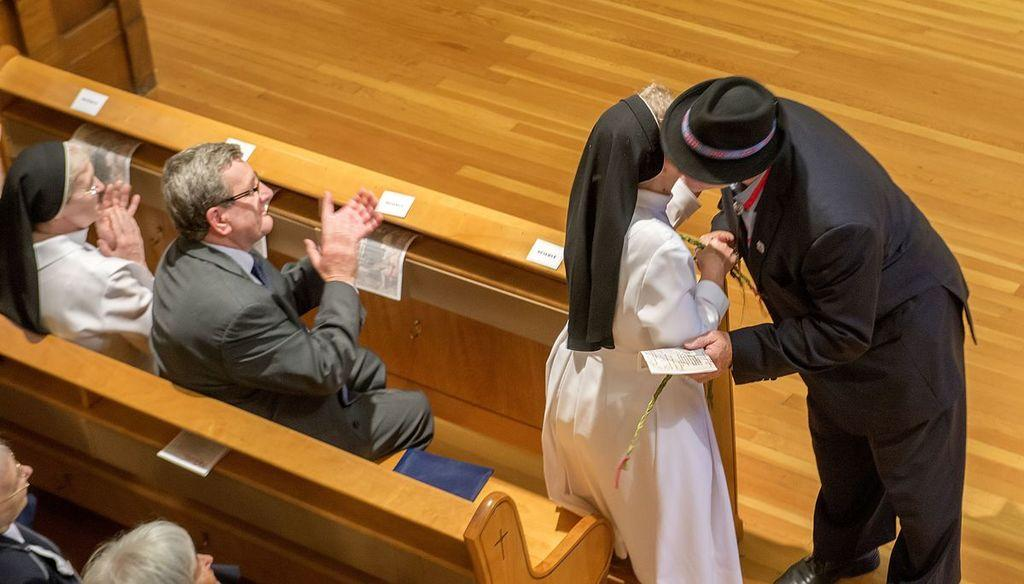What are the persons in the image doing? There are persons sitting on benches and persons standing on the floor in the image. Can you describe the positions of the persons in the image? Yes, some persons are sitting on benches, while others are standing on the floor. What type of show is being performed by the persons in the image? There is no indication in the image that a show is being performed; the persons are simply sitting or standing. Can you tell me where the cellar is located in the image? There is no cellar present in the image. 